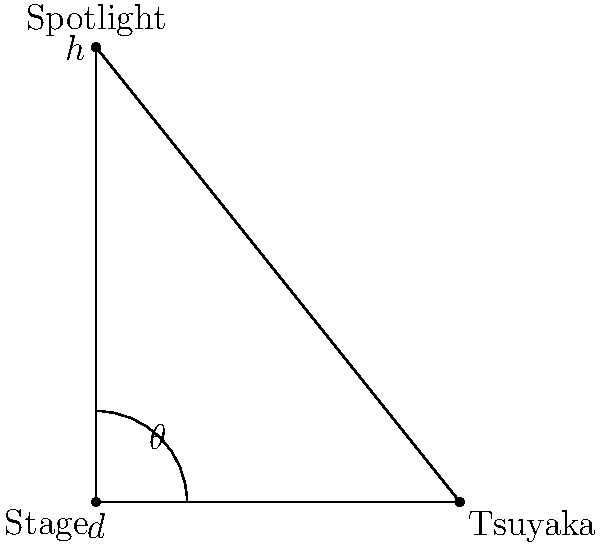At a concert venue, a spotlight needs to be positioned to illuminate Tsuyaka Uchino on stage. The spotlight is mounted 5 meters above the stage floor, and Tsuyaka is standing 4 meters away from the base of the spotlight. What angle $\theta$ (in degrees) should the spotlight be tilted down from the vertical to directly illuminate Tsuyaka? Let's approach this step-by-step:

1) We can see that this forms a right-angled triangle, where:
   - The vertical height of the spotlight is 5 meters (h)
   - The horizontal distance to Tsuyaka is 4 meters (d)
   - The angle we're looking for is $\theta$

2) In this right-angled triangle, we can use the tangent function:

   $$\tan(\theta) = \frac{\text{opposite}}{\text{adjacent}} = \frac{d}{h} = \frac{4}{5}$$

3) To find $\theta$, we need to use the inverse tangent (arctan or $\tan^{-1}$):

   $$\theta = \tan^{-1}(\frac{4}{5})$$

4) Using a calculator or computational tool:

   $$\theta \approx 38.66^\circ$$

5) Rounding to the nearest degree:

   $$\theta \approx 39^\circ$$

Therefore, the spotlight should be tilted down approximately 39° from the vertical to directly illuminate Tsuyaka Uchino.
Answer: 39° 